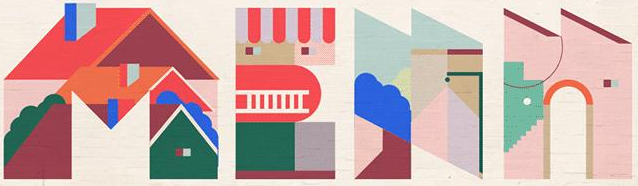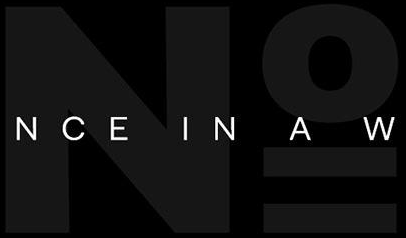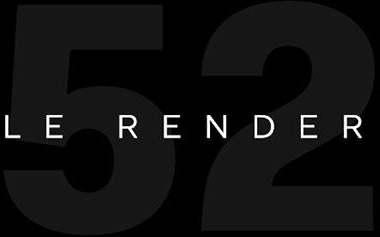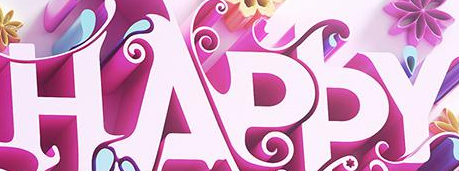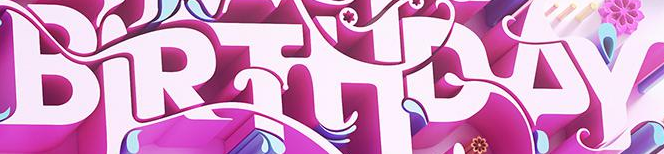What words can you see in these images in sequence, separated by a semicolon? MEAN; No; 52; HAPPY; BIRTHDAY 